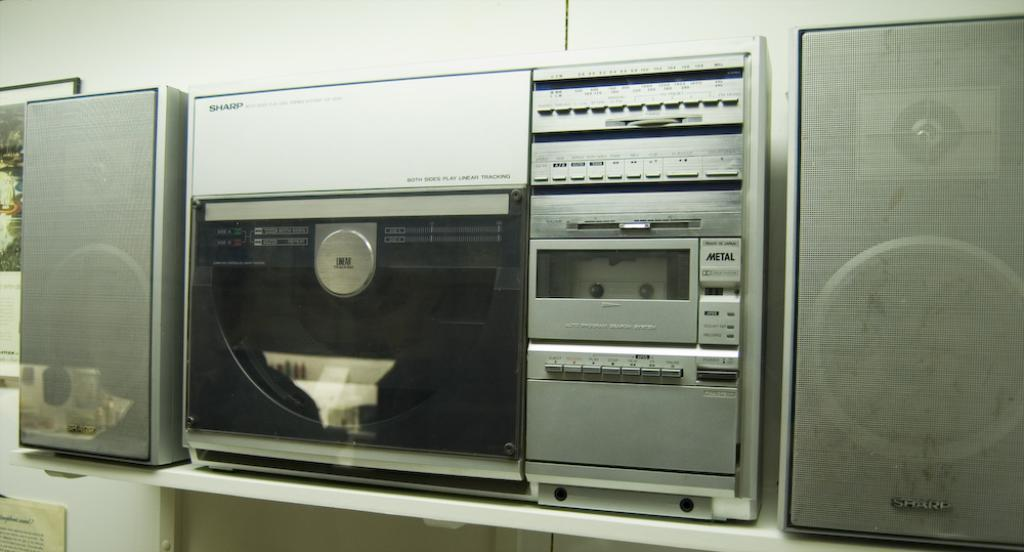What device is present in the image for playing music? There is a music player in the image. What accompanies the music player to amplify the sound? There are speakers in the image. Where are the music player and speakers located? They are on a platform. What can be seen on the wall in the background of the image? There is a poster in the image. What other object is present in the background of the image? There is a photo frame in the background of the image. What type of business is being conducted in the image? There is no indication of a business being conducted in the image; it primarily features a music player, speakers, and related objects. 